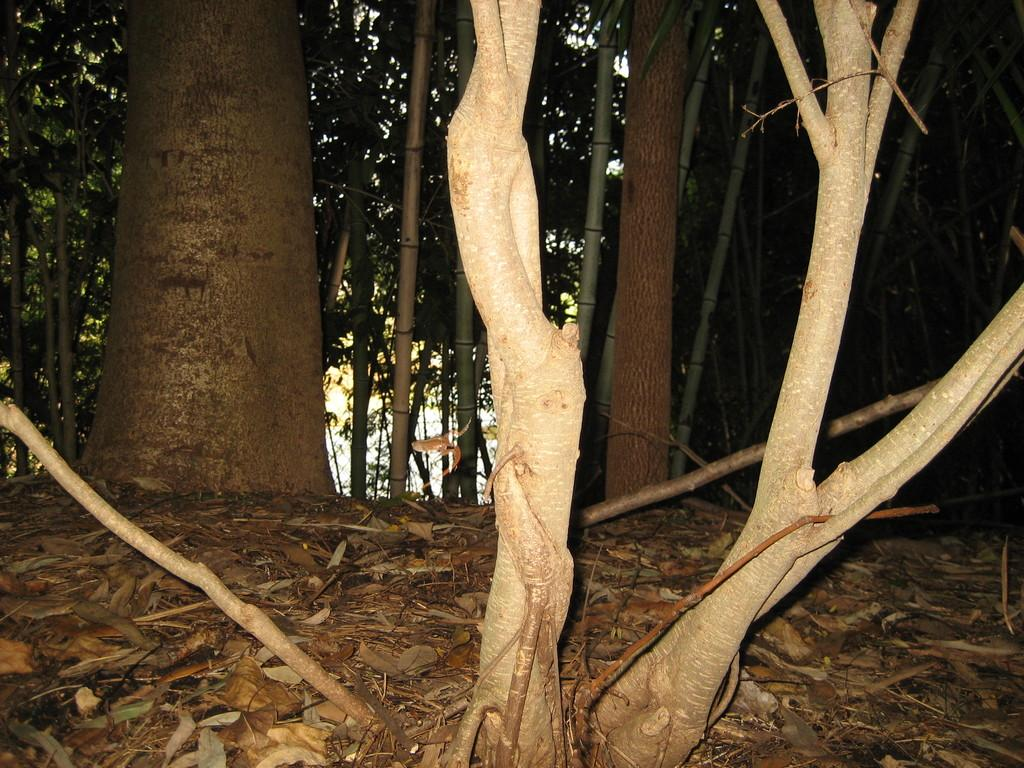What objects are in the foreground of the image? There are trunks in the foreground of the image. What can be seen in the background of the image? There are trees and dry leaves in the background of the image. Can you tell me how many rabbits are hiding among the trunks in the image? There are no rabbits present in the image; it only features trunks and trees in the background. What type of dinosaurs can be seen roaming around in the image? There are no dinosaurs present in the image; it only features trunks and trees in the background. 